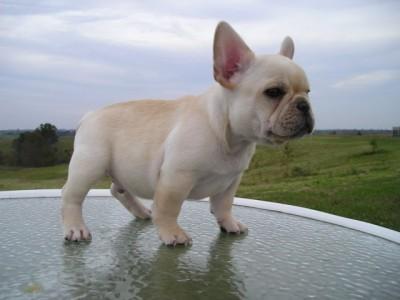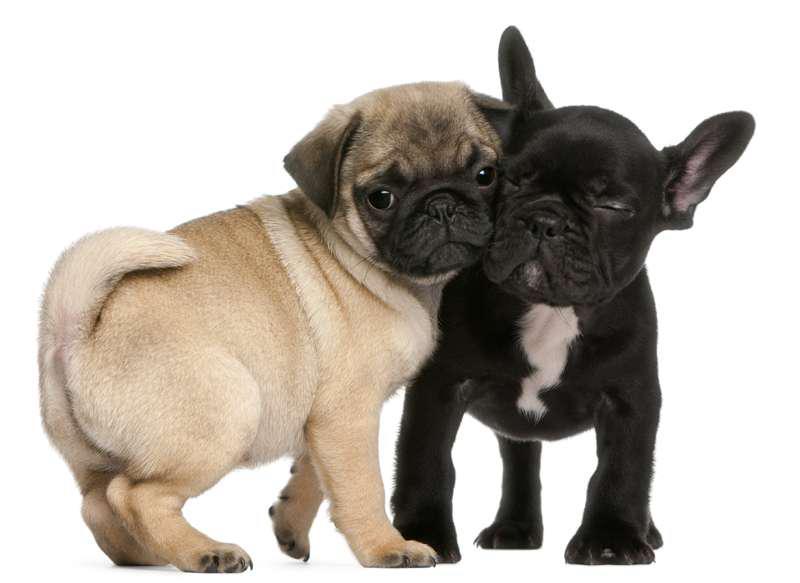The first image is the image on the left, the second image is the image on the right. Evaluate the accuracy of this statement regarding the images: "Each image contains one bulldog, and the dog on the left is standing while the dog on the right is sitting.". Is it true? Answer yes or no. No. The first image is the image on the left, the second image is the image on the right. For the images displayed, is the sentence "No less than one dog is outside." factually correct? Answer yes or no. Yes. 